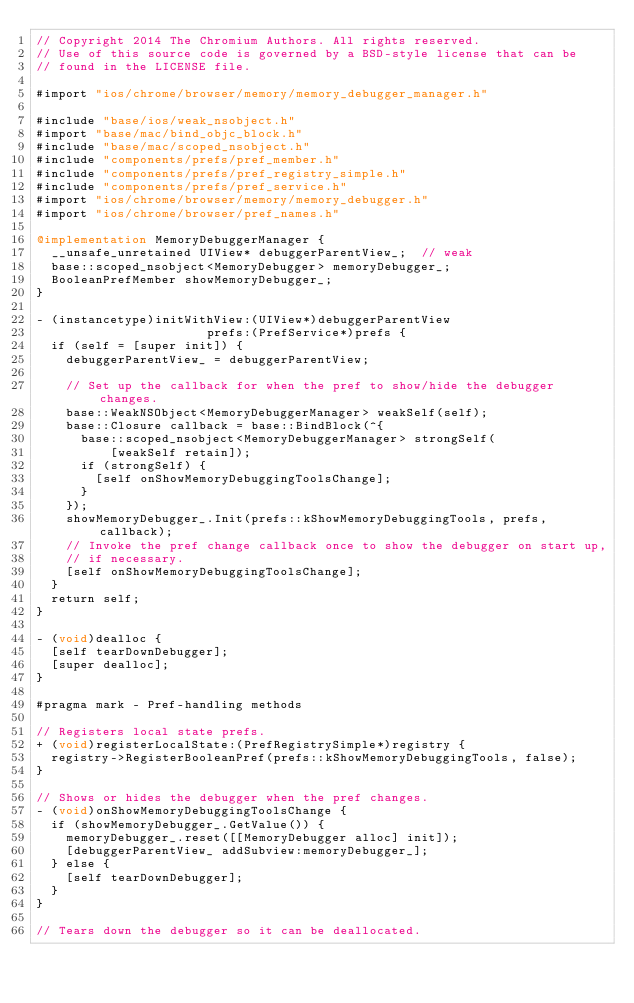<code> <loc_0><loc_0><loc_500><loc_500><_ObjectiveC_>// Copyright 2014 The Chromium Authors. All rights reserved.
// Use of this source code is governed by a BSD-style license that can be
// found in the LICENSE file.

#import "ios/chrome/browser/memory/memory_debugger_manager.h"

#include "base/ios/weak_nsobject.h"
#import "base/mac/bind_objc_block.h"
#include "base/mac/scoped_nsobject.h"
#include "components/prefs/pref_member.h"
#include "components/prefs/pref_registry_simple.h"
#include "components/prefs/pref_service.h"
#import "ios/chrome/browser/memory/memory_debugger.h"
#import "ios/chrome/browser/pref_names.h"

@implementation MemoryDebuggerManager {
  __unsafe_unretained UIView* debuggerParentView_;  // weak
  base::scoped_nsobject<MemoryDebugger> memoryDebugger_;
  BooleanPrefMember showMemoryDebugger_;
}

- (instancetype)initWithView:(UIView*)debuggerParentView
                       prefs:(PrefService*)prefs {
  if (self = [super init]) {
    debuggerParentView_ = debuggerParentView;

    // Set up the callback for when the pref to show/hide the debugger changes.
    base::WeakNSObject<MemoryDebuggerManager> weakSelf(self);
    base::Closure callback = base::BindBlock(^{
      base::scoped_nsobject<MemoryDebuggerManager> strongSelf(
          [weakSelf retain]);
      if (strongSelf) {
        [self onShowMemoryDebuggingToolsChange];
      }
    });
    showMemoryDebugger_.Init(prefs::kShowMemoryDebuggingTools, prefs, callback);
    // Invoke the pref change callback once to show the debugger on start up,
    // if necessary.
    [self onShowMemoryDebuggingToolsChange];
  }
  return self;
}

- (void)dealloc {
  [self tearDownDebugger];
  [super dealloc];
}

#pragma mark - Pref-handling methods

// Registers local state prefs.
+ (void)registerLocalState:(PrefRegistrySimple*)registry {
  registry->RegisterBooleanPref(prefs::kShowMemoryDebuggingTools, false);
}

// Shows or hides the debugger when the pref changes.
- (void)onShowMemoryDebuggingToolsChange {
  if (showMemoryDebugger_.GetValue()) {
    memoryDebugger_.reset([[MemoryDebugger alloc] init]);
    [debuggerParentView_ addSubview:memoryDebugger_];
  } else {
    [self tearDownDebugger];
  }
}

// Tears down the debugger so it can be deallocated.</code> 